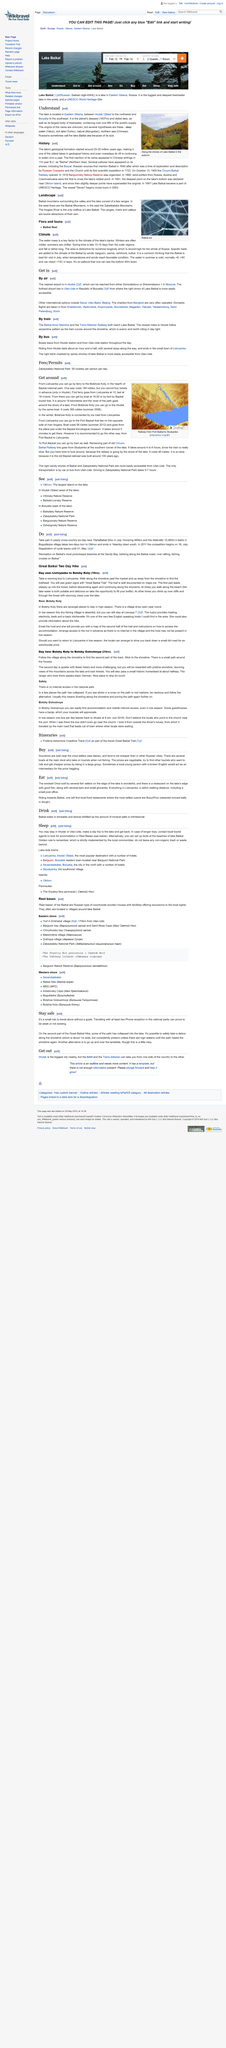Outline some significant characteristics in this image. Yes, it is possible to safely take a detour along the shoreline of the second part of the Great Baikal Hike, as the shoreline path is consistently present and approximately 1 meter wide, unless there are high waters, allowing for a safe and scenic journey. The lake is located in Eastern Siberia, specifically between Irkutsk Oblast and the republic of Buryatia, making it a prime destination for those interested in exploring the region's natural beauty. There are three methods of travel available to reach Lake Baikal: train, bus, and air travel. Ulan-Ude is the best place to access the right bank of Lake Baikal as it offers easy access to this side of the lake. The image depicts a scenic view of the shorelines of Lake Baikal, a world-famous freshwater lake located in Russia, known for its unique ecosystem and crystal-clear waters. 